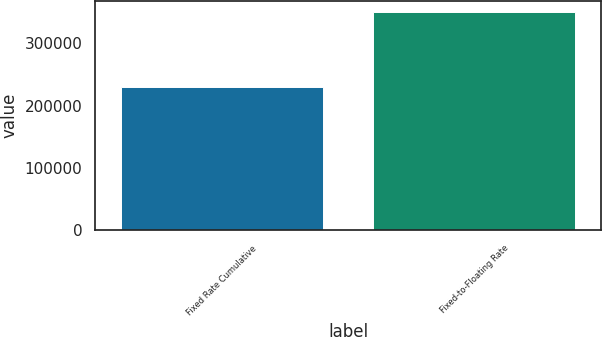Convert chart to OTSL. <chart><loc_0><loc_0><loc_500><loc_500><bar_chart><fcel>Fixed Rate Cumulative<fcel>Fixed-to-Floating Rate<nl><fcel>230000<fcel>350000<nl></chart> 